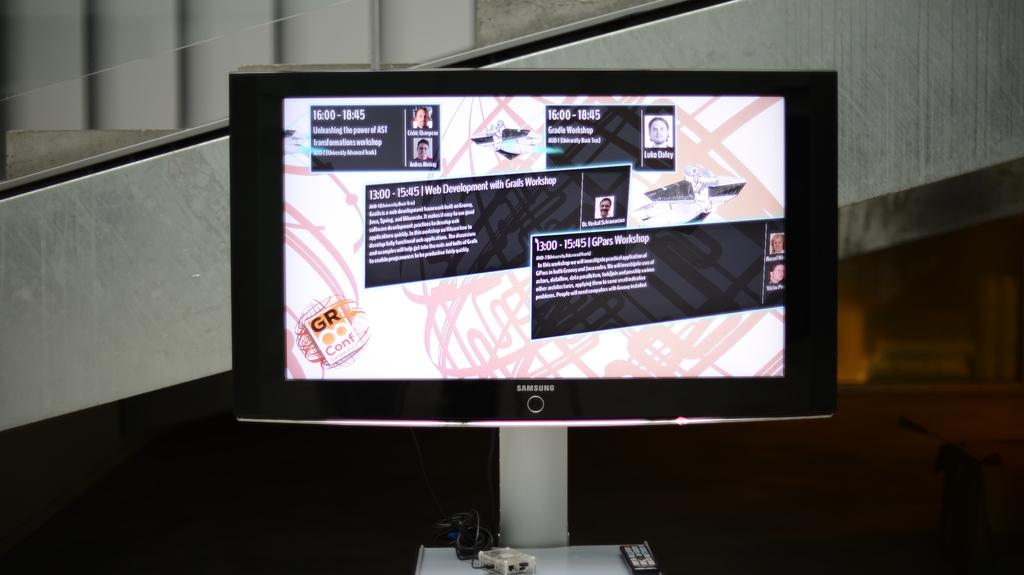Provide a one-sentence caption for the provided image. A Samsung computer monitor showing paragraphs of text and photos. 